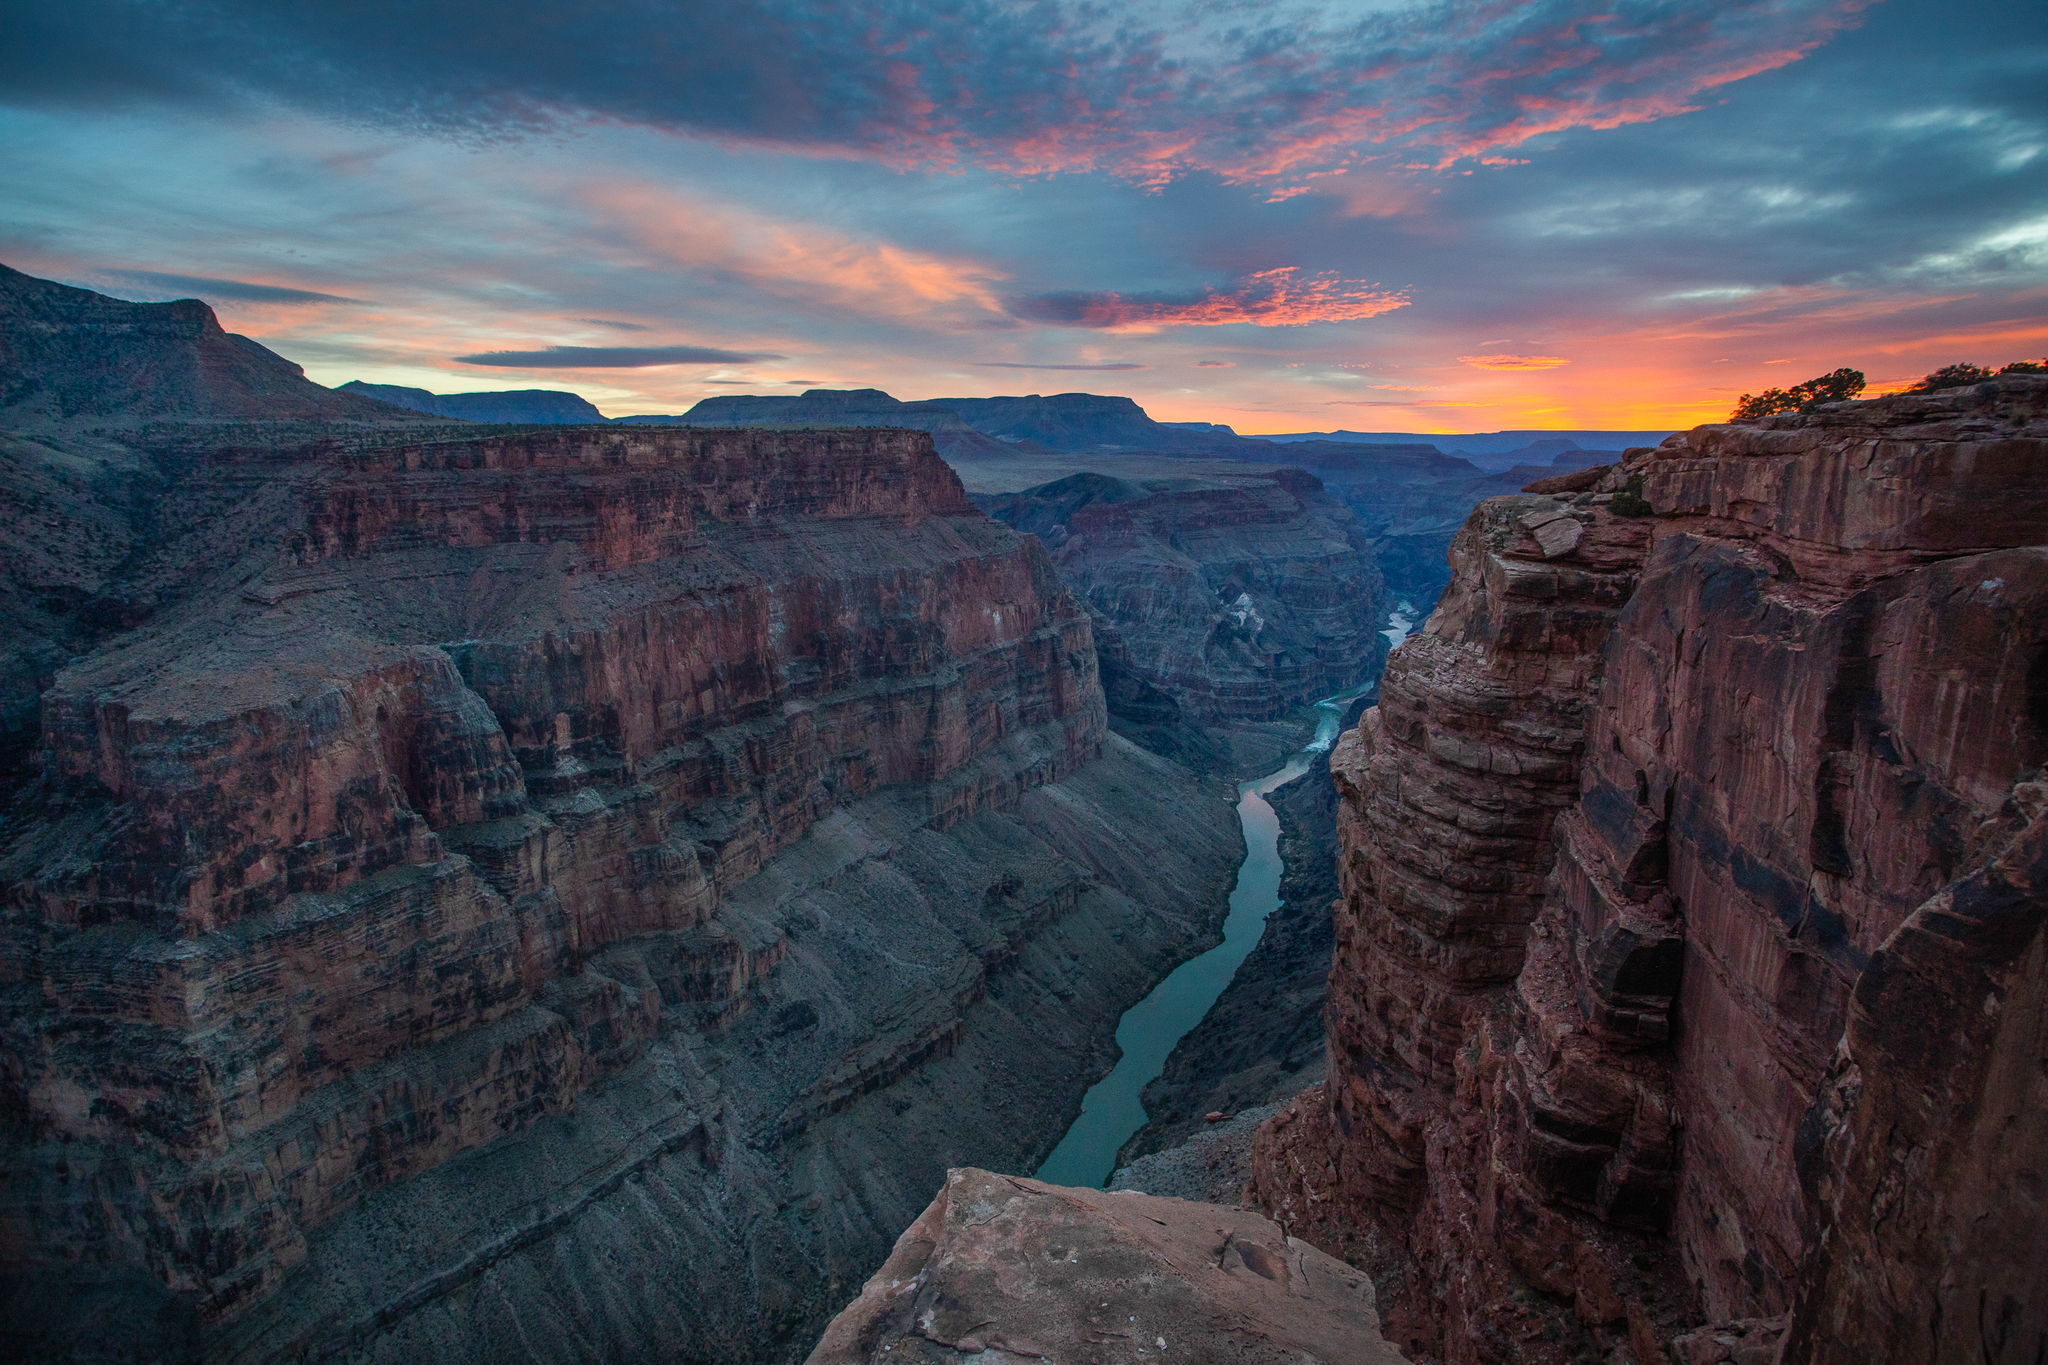Can you explain the significance of the color variations in the canyon walls? Each color layer in the canyon walls represents different geological periods, with variations caused by mineral types and environmental changes over time. The reds and oranges, for example, often contain iron oxide, while brighter whites and grays might indicate sandstone or limestone rich in different mineral content. These layers act almost like a natural history book, storing information about the Earth's past climate and ecosystems. 